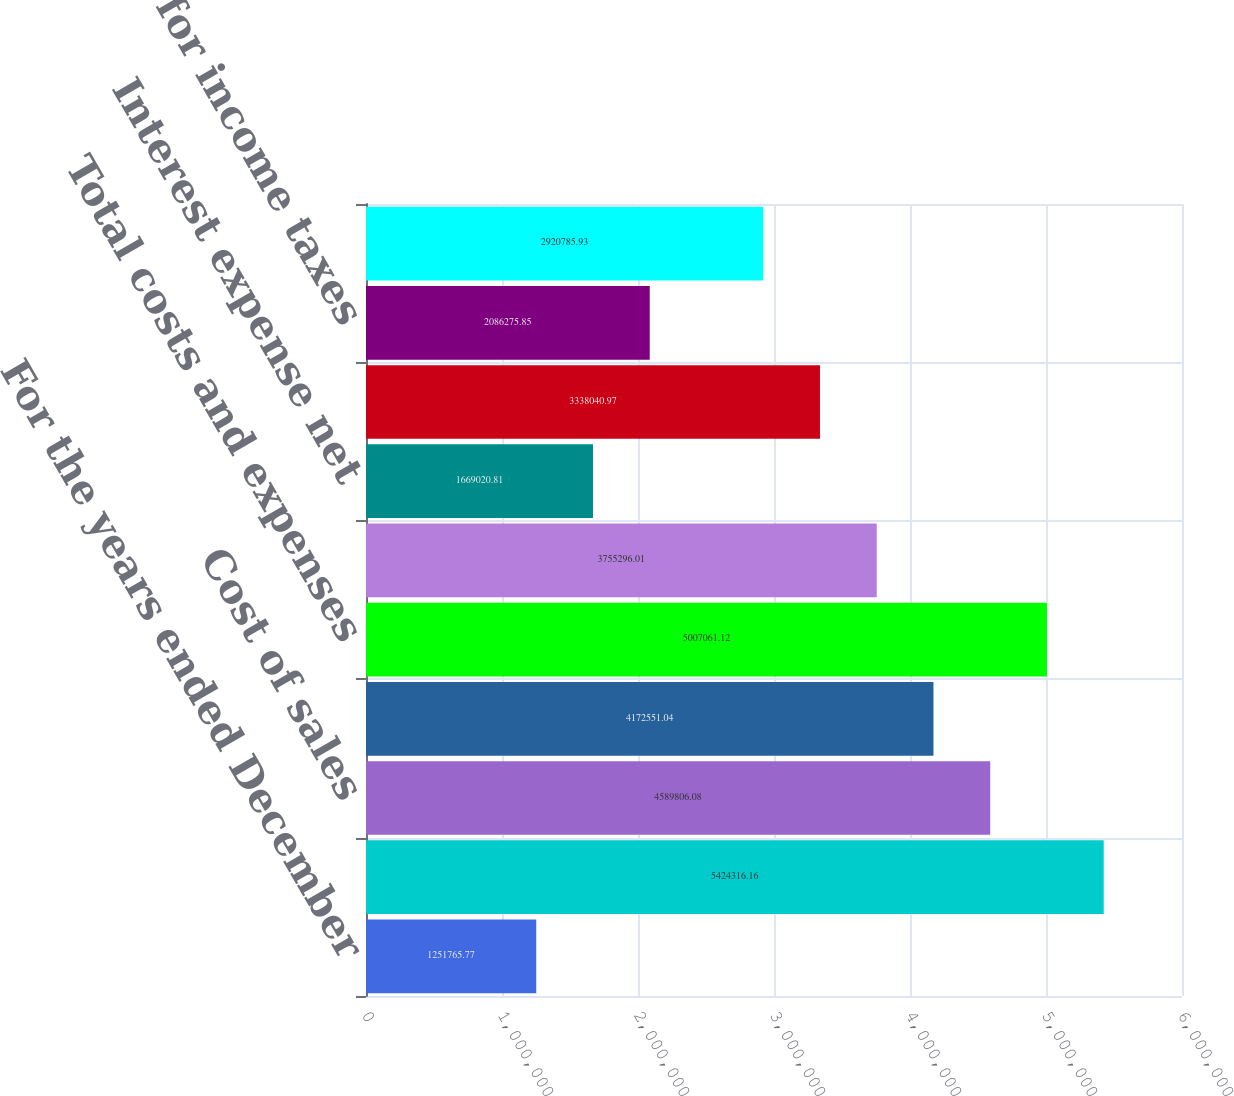<chart> <loc_0><loc_0><loc_500><loc_500><bar_chart><fcel>For the years ended December<fcel>Net Sales<fcel>Cost of sales<fcel>Selling marketing and<fcel>Total costs and expenses<fcel>Income before Interest and<fcel>Interest expense net<fcel>Income before Income Taxes<fcel>Provision for income taxes<fcel>Accounting Change<nl><fcel>1.25177e+06<fcel>5.42432e+06<fcel>4.58981e+06<fcel>4.17255e+06<fcel>5.00706e+06<fcel>3.7553e+06<fcel>1.66902e+06<fcel>3.33804e+06<fcel>2.08628e+06<fcel>2.92079e+06<nl></chart> 